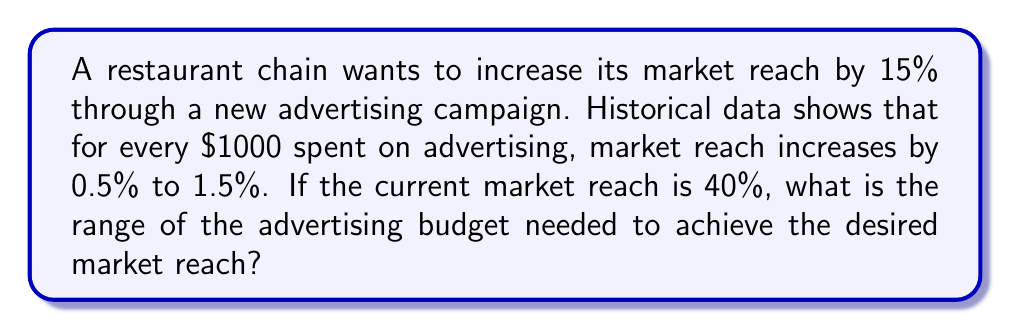Could you help me with this problem? Let's approach this step-by-step:

1) Current market reach: 40%
   Desired increase: 15%
   Target market reach: 40% + 15% = 55%

2) We need to determine the range of spending needed to increase market reach by 15%.

3) Lower bound calculation:
   - Best case scenario: $1000 increases reach by 1.5%
   - Number of $1000 units needed: $\frac{15\%}{1.5\%} = 10$
   - Lower bound of budget: $10 \times $1000 = $10,000

4) Upper bound calculation:
   - Worst case scenario: $1000 increases reach by 0.5%
   - Number of $1000 units needed: $\frac{15\%}{0.5\%} = 30$
   - Upper bound of budget: $30 \times $1000 = $30,000

5) Therefore, the range of the advertising budget needed is:

   $$10,000 \leq \text{Budget} \leq 30,000$$
Answer: $[10000, 30000] 